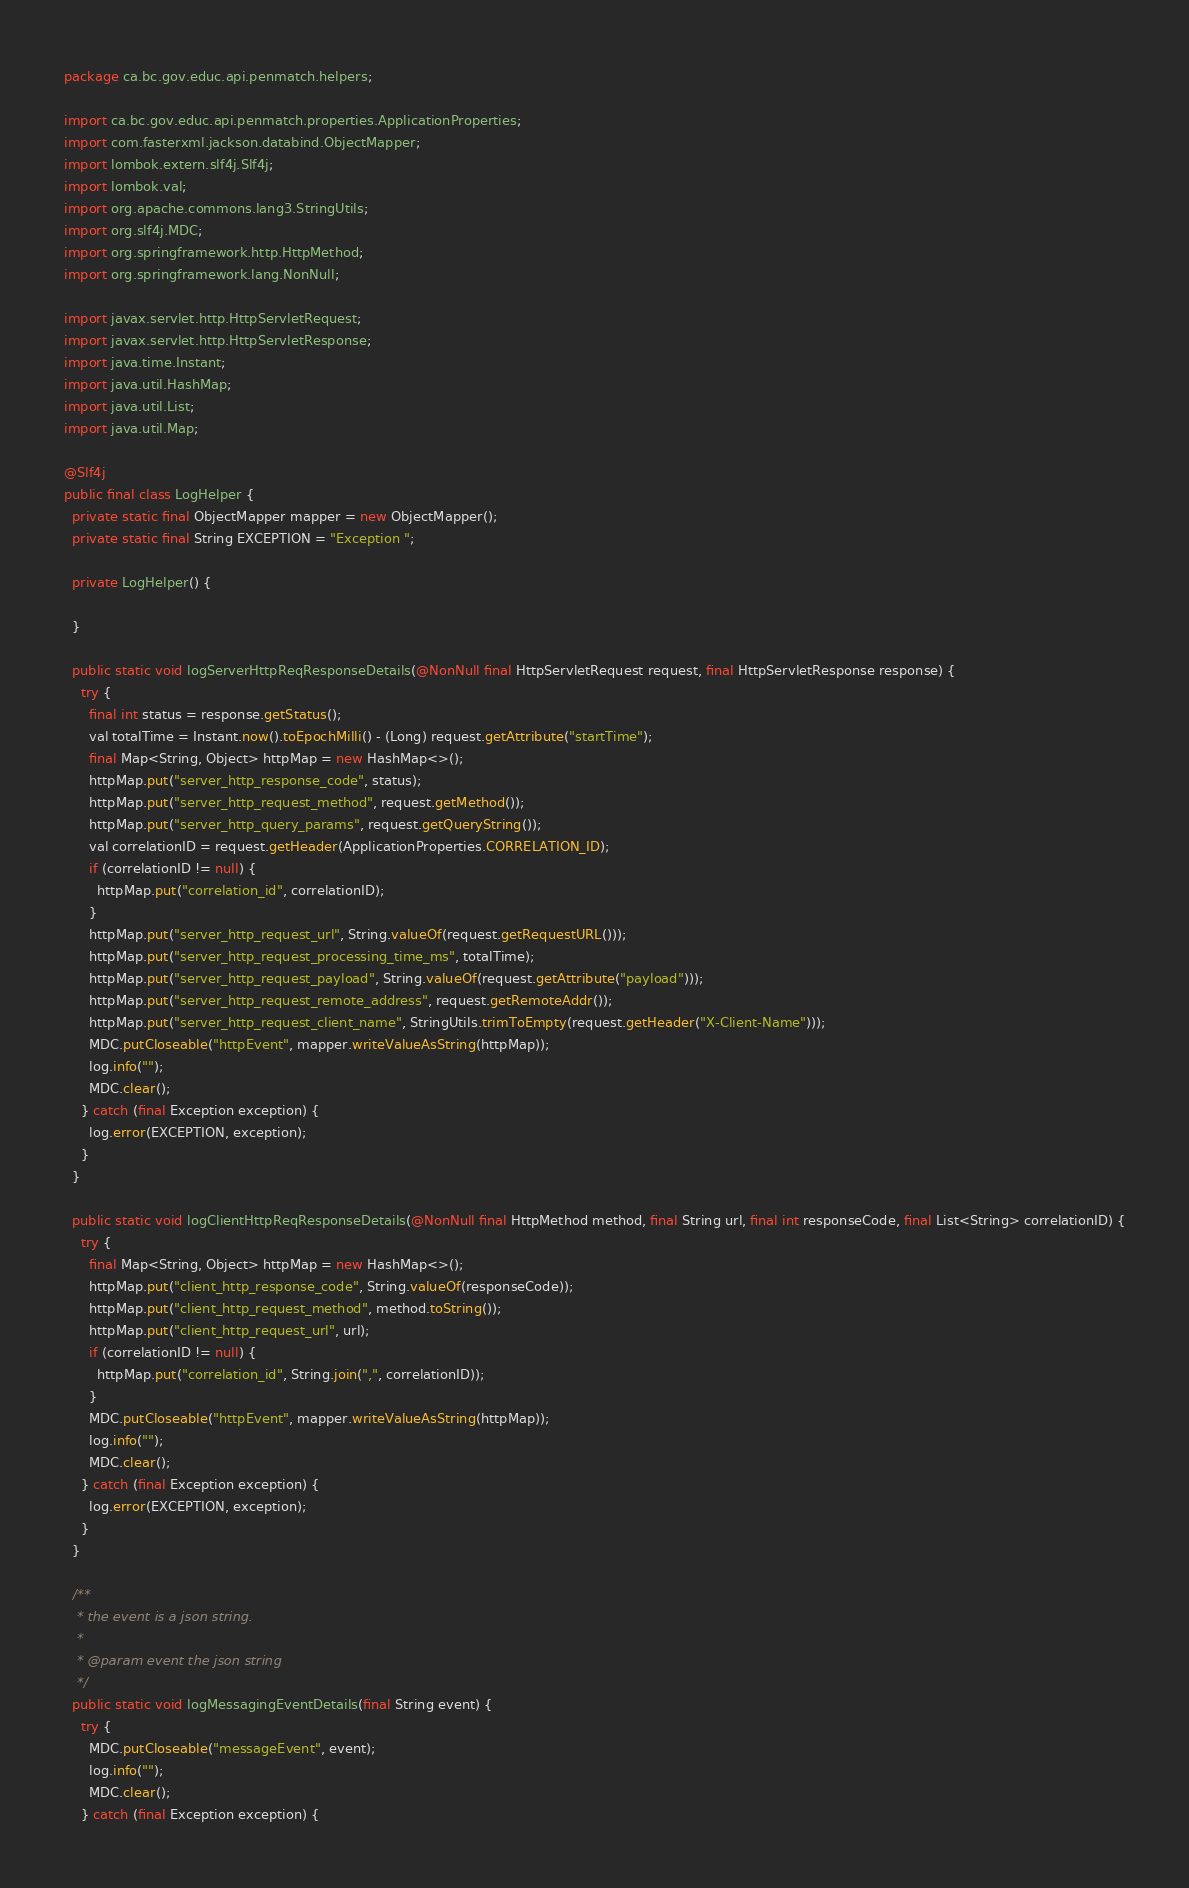Convert code to text. <code><loc_0><loc_0><loc_500><loc_500><_Java_>package ca.bc.gov.educ.api.penmatch.helpers;

import ca.bc.gov.educ.api.penmatch.properties.ApplicationProperties;
import com.fasterxml.jackson.databind.ObjectMapper;
import lombok.extern.slf4j.Slf4j;
import lombok.val;
import org.apache.commons.lang3.StringUtils;
import org.slf4j.MDC;
import org.springframework.http.HttpMethod;
import org.springframework.lang.NonNull;

import javax.servlet.http.HttpServletRequest;
import javax.servlet.http.HttpServletResponse;
import java.time.Instant;
import java.util.HashMap;
import java.util.List;
import java.util.Map;

@Slf4j
public final class LogHelper {
  private static final ObjectMapper mapper = new ObjectMapper();
  private static final String EXCEPTION = "Exception ";

  private LogHelper() {

  }

  public static void logServerHttpReqResponseDetails(@NonNull final HttpServletRequest request, final HttpServletResponse response) {
    try {
      final int status = response.getStatus();
      val totalTime = Instant.now().toEpochMilli() - (Long) request.getAttribute("startTime");
      final Map<String, Object> httpMap = new HashMap<>();
      httpMap.put("server_http_response_code", status);
      httpMap.put("server_http_request_method", request.getMethod());
      httpMap.put("server_http_query_params", request.getQueryString());
      val correlationID = request.getHeader(ApplicationProperties.CORRELATION_ID);
      if (correlationID != null) {
        httpMap.put("correlation_id", correlationID);
      }
      httpMap.put("server_http_request_url", String.valueOf(request.getRequestURL()));
      httpMap.put("server_http_request_processing_time_ms", totalTime);
      httpMap.put("server_http_request_payload", String.valueOf(request.getAttribute("payload")));
      httpMap.put("server_http_request_remote_address", request.getRemoteAddr());
      httpMap.put("server_http_request_client_name", StringUtils.trimToEmpty(request.getHeader("X-Client-Name")));
      MDC.putCloseable("httpEvent", mapper.writeValueAsString(httpMap));
      log.info("");
      MDC.clear();
    } catch (final Exception exception) {
      log.error(EXCEPTION, exception);
    }
  }

  public static void logClientHttpReqResponseDetails(@NonNull final HttpMethod method, final String url, final int responseCode, final List<String> correlationID) {
    try {
      final Map<String, Object> httpMap = new HashMap<>();
      httpMap.put("client_http_response_code", String.valueOf(responseCode));
      httpMap.put("client_http_request_method", method.toString());
      httpMap.put("client_http_request_url", url);
      if (correlationID != null) {
        httpMap.put("correlation_id", String.join(",", correlationID));
      }
      MDC.putCloseable("httpEvent", mapper.writeValueAsString(httpMap));
      log.info("");
      MDC.clear();
    } catch (final Exception exception) {
      log.error(EXCEPTION, exception);
    }
  }

  /**
   * the event is a json string.
   *
   * @param event the json string
   */
  public static void logMessagingEventDetails(final String event) {
    try {
      MDC.putCloseable("messageEvent", event);
      log.info("");
      MDC.clear();
    } catch (final Exception exception) {</code> 